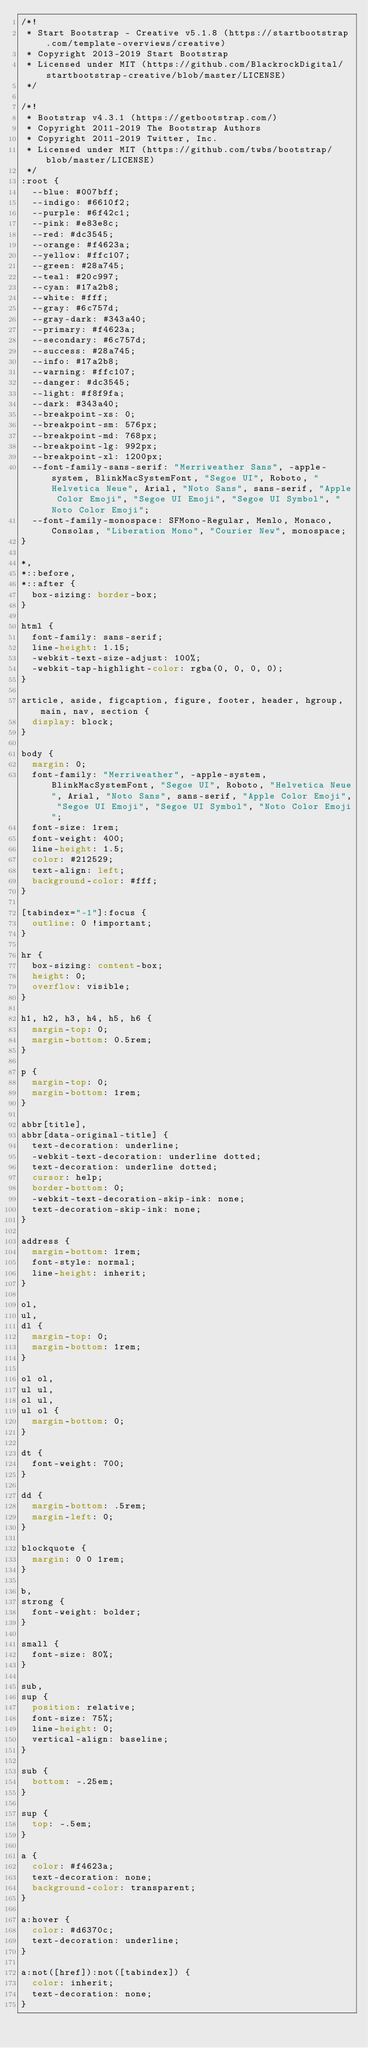<code> <loc_0><loc_0><loc_500><loc_500><_CSS_>/*!
 * Start Bootstrap - Creative v5.1.8 (https://startbootstrap.com/template-overviews/creative)
 * Copyright 2013-2019 Start Bootstrap
 * Licensed under MIT (https://github.com/BlackrockDigital/startbootstrap-creative/blob/master/LICENSE)
 */

/*!
 * Bootstrap v4.3.1 (https://getbootstrap.com/)
 * Copyright 2011-2019 The Bootstrap Authors
 * Copyright 2011-2019 Twitter, Inc.
 * Licensed under MIT (https://github.com/twbs/bootstrap/blob/master/LICENSE)
 */
:root {
  --blue: #007bff;
  --indigo: #6610f2;
  --purple: #6f42c1;
  --pink: #e83e8c;
  --red: #dc3545;
  --orange: #f4623a;
  --yellow: #ffc107;
  --green: #28a745;
  --teal: #20c997;
  --cyan: #17a2b8;
  --white: #fff;
  --gray: #6c757d;
  --gray-dark: #343a40;
  --primary: #f4623a;
  --secondary: #6c757d;
  --success: #28a745;
  --info: #17a2b8;
  --warning: #ffc107;
  --danger: #dc3545;
  --light: #f8f9fa;
  --dark: #343a40;
  --breakpoint-xs: 0;
  --breakpoint-sm: 576px;
  --breakpoint-md: 768px;
  --breakpoint-lg: 992px;
  --breakpoint-xl: 1200px;
  --font-family-sans-serif: "Merriweather Sans", -apple-system, BlinkMacSystemFont, "Segoe UI", Roboto, "Helvetica Neue", Arial, "Noto Sans", sans-serif, "Apple Color Emoji", "Segoe UI Emoji", "Segoe UI Symbol", "Noto Color Emoji";
  --font-family-monospace: SFMono-Regular, Menlo, Monaco, Consolas, "Liberation Mono", "Courier New", monospace;
}

*,
*::before,
*::after {
  box-sizing: border-box;
}

html {
  font-family: sans-serif;
  line-height: 1.15;
  -webkit-text-size-adjust: 100%;
  -webkit-tap-highlight-color: rgba(0, 0, 0, 0);
}

article, aside, figcaption, figure, footer, header, hgroup, main, nav, section {
  display: block;
}

body {
  margin: 0;
  font-family: "Merriweather", -apple-system, BlinkMacSystemFont, "Segoe UI", Roboto, "Helvetica Neue", Arial, "Noto Sans", sans-serif, "Apple Color Emoji", "Segoe UI Emoji", "Segoe UI Symbol", "Noto Color Emoji";
  font-size: 1rem;
  font-weight: 400;
  line-height: 1.5;
  color: #212529;
  text-align: left;
  background-color: #fff;
}

[tabindex="-1"]:focus {
  outline: 0 !important;
}

hr {
  box-sizing: content-box;
  height: 0;
  overflow: visible;
}

h1, h2, h3, h4, h5, h6 {
  margin-top: 0;
  margin-bottom: 0.5rem;
}

p {
  margin-top: 0;
  margin-bottom: 1rem;
}

abbr[title],
abbr[data-original-title] {
  text-decoration: underline;
  -webkit-text-decoration: underline dotted;
  text-decoration: underline dotted;
  cursor: help;
  border-bottom: 0;
  -webkit-text-decoration-skip-ink: none;
  text-decoration-skip-ink: none;
}

address {
  margin-bottom: 1rem;
  font-style: normal;
  line-height: inherit;
}

ol,
ul,
dl {
  margin-top: 0;
  margin-bottom: 1rem;
}

ol ol,
ul ul,
ol ul,
ul ol {
  margin-bottom: 0;
}

dt {
  font-weight: 700;
}

dd {
  margin-bottom: .5rem;
  margin-left: 0;
}

blockquote {
  margin: 0 0 1rem;
}

b,
strong {
  font-weight: bolder;
}

small {
  font-size: 80%;
}

sub,
sup {
  position: relative;
  font-size: 75%;
  line-height: 0;
  vertical-align: baseline;
}

sub {
  bottom: -.25em;
}

sup {
  top: -.5em;
}

a {
  color: #f4623a;
  text-decoration: none;
  background-color: transparent;
}

a:hover {
  color: #d6370c;
  text-decoration: underline;
}

a:not([href]):not([tabindex]) {
  color: inherit;
  text-decoration: none;
}
</code> 